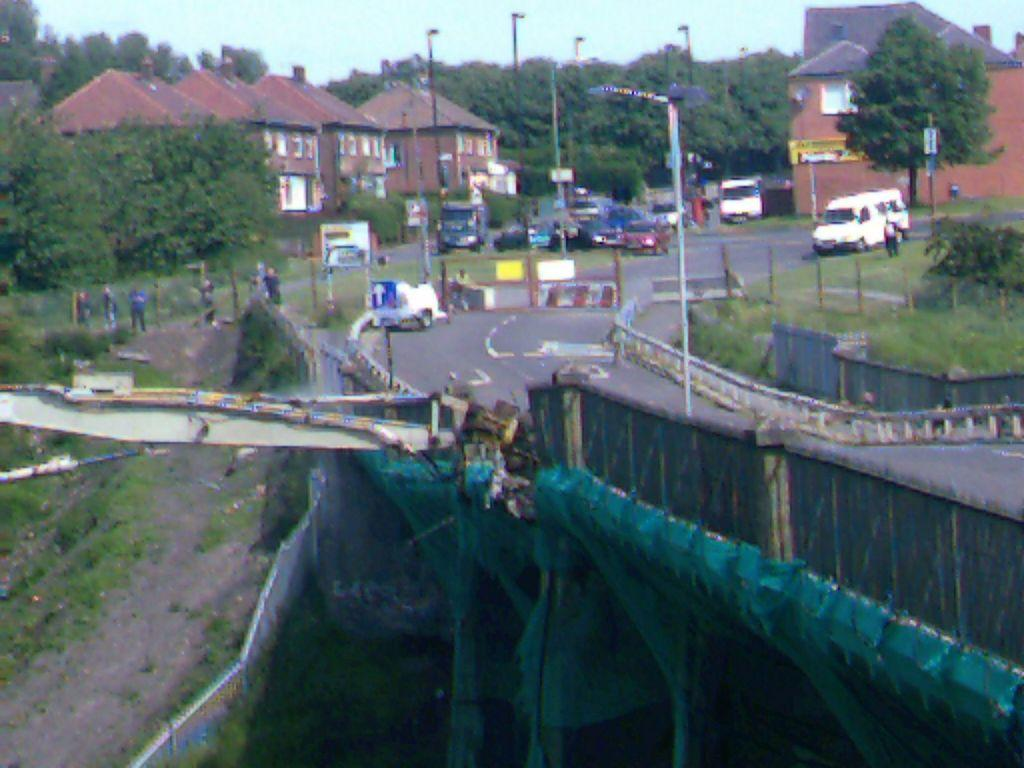What types of objects can be seen in the image? There are vehicles, buildings, trees, poles, lights, grass, and people in the image. What is the purpose of the boards with text in the image? The boards with text might be used for advertisement or information purposes. What is the background of the image? The sky is visible in the background of the image. What is the wall in the image made of? The wall in the image is likely made of brick or concrete. How many people are present in the image? There are people in the image, but the exact number is not specified. What type of property is being advertised on the bit in the image? There is no bit present in the image, and therefore no such advertisement can be observed. 